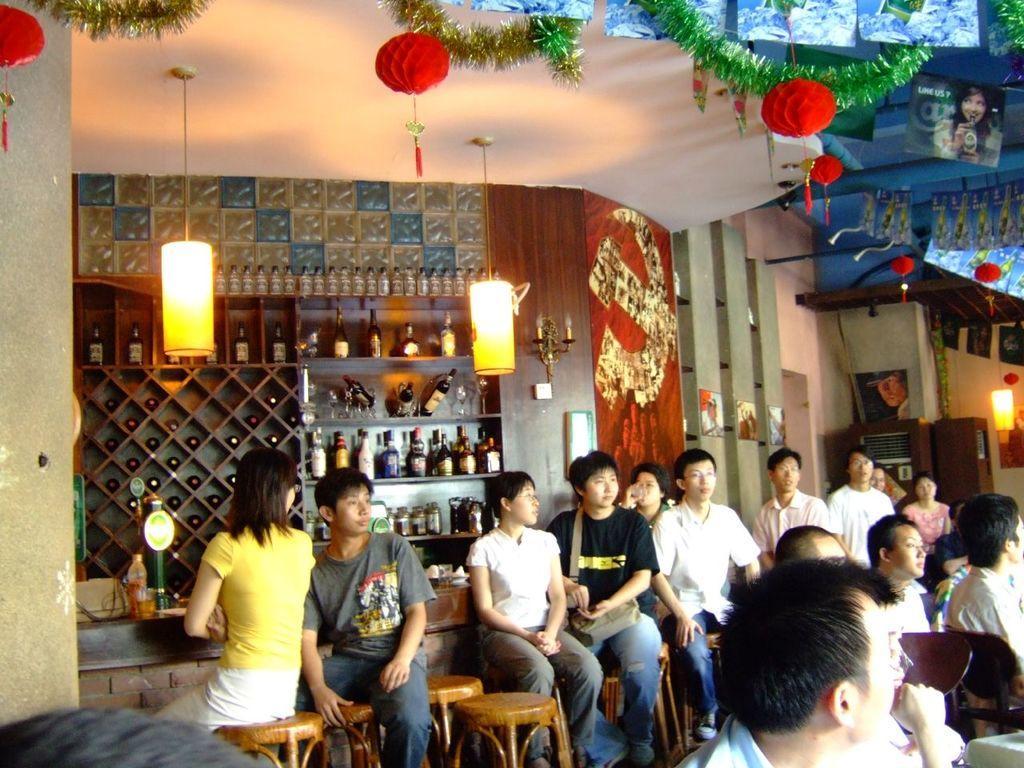Describe this image in one or two sentences. There are group of people sitting on stools. The person in the middle, is wearing a bag. In the background, there are bottles in the shelf's, decorative items. On the right hand side, there is a light and some wood items. On the left hand side, there is a pillar and head of a person. 